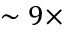<formula> <loc_0><loc_0><loc_500><loc_500>\sim 9 \times</formula> 